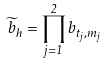Convert formula to latex. <formula><loc_0><loc_0><loc_500><loc_500>\widetilde { b } _ { h } = \prod _ { j = 1 } ^ { 2 } b _ { t _ { j } , m _ { j } }</formula> 